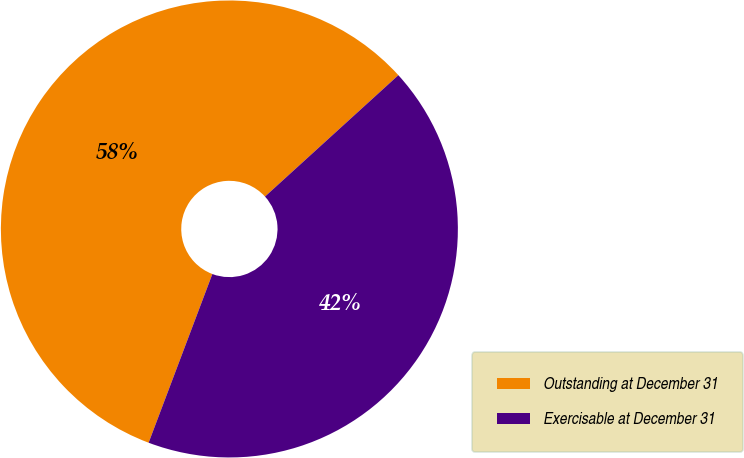<chart> <loc_0><loc_0><loc_500><loc_500><pie_chart><fcel>Outstanding at December 31<fcel>Exercisable at December 31<nl><fcel>57.5%<fcel>42.5%<nl></chart> 